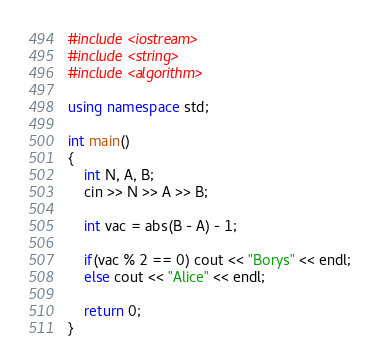Convert code to text. <code><loc_0><loc_0><loc_500><loc_500><_C++_>#include <iostream>
#include <string>
#include <algorithm>

using namespace std;

int main()
{
    int N, A, B;
    cin >> N >> A >> B;

    int vac = abs(B - A) - 1;

    if(vac % 2 == 0) cout << "Borys" << endl;
    else cout << "Alice" << endl;

    return 0;
}</code> 